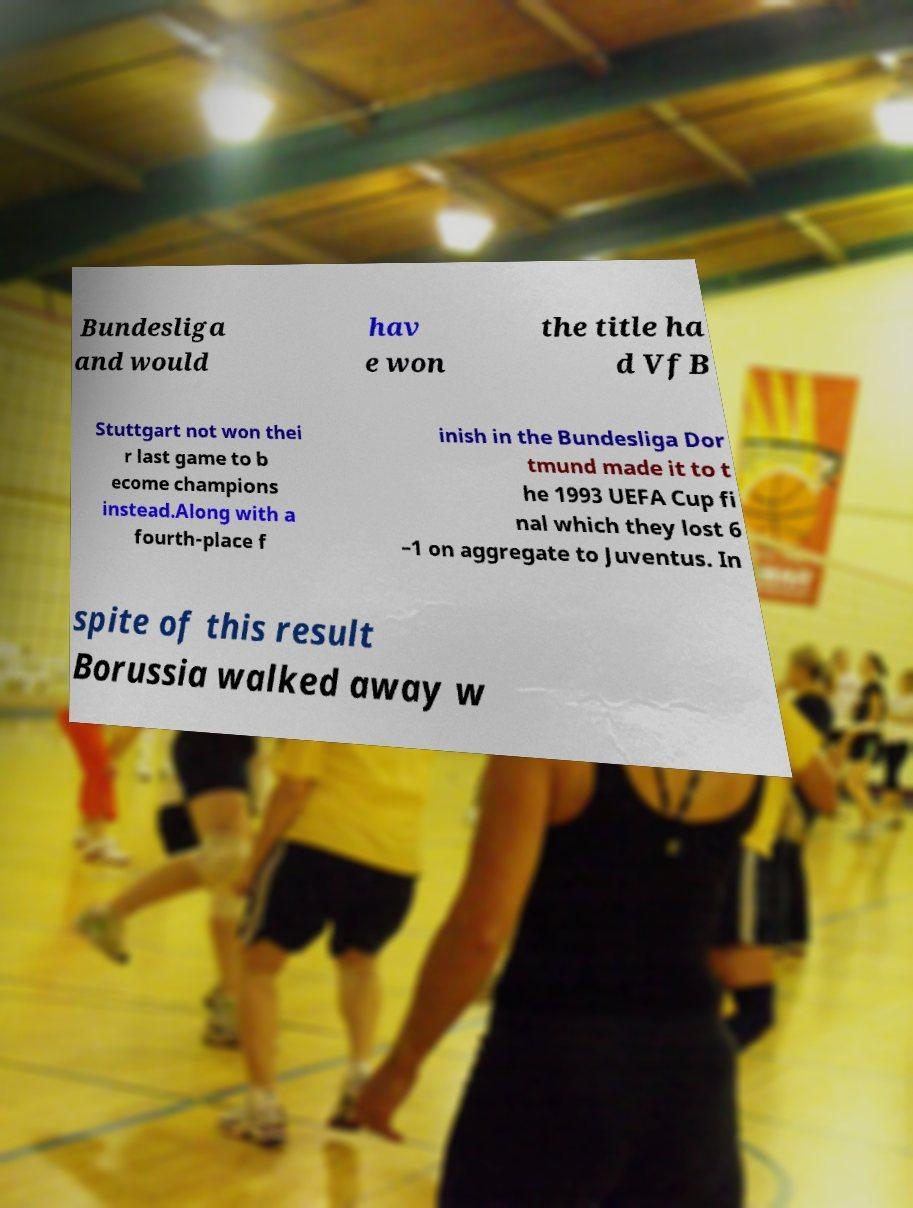Please read and relay the text visible in this image. What does it say? Bundesliga and would hav e won the title ha d VfB Stuttgart not won thei r last game to b ecome champions instead.Along with a fourth-place f inish in the Bundesliga Dor tmund made it to t he 1993 UEFA Cup fi nal which they lost 6 –1 on aggregate to Juventus. In spite of this result Borussia walked away w 